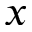Convert formula to latex. <formula><loc_0><loc_0><loc_500><loc_500>x</formula> 